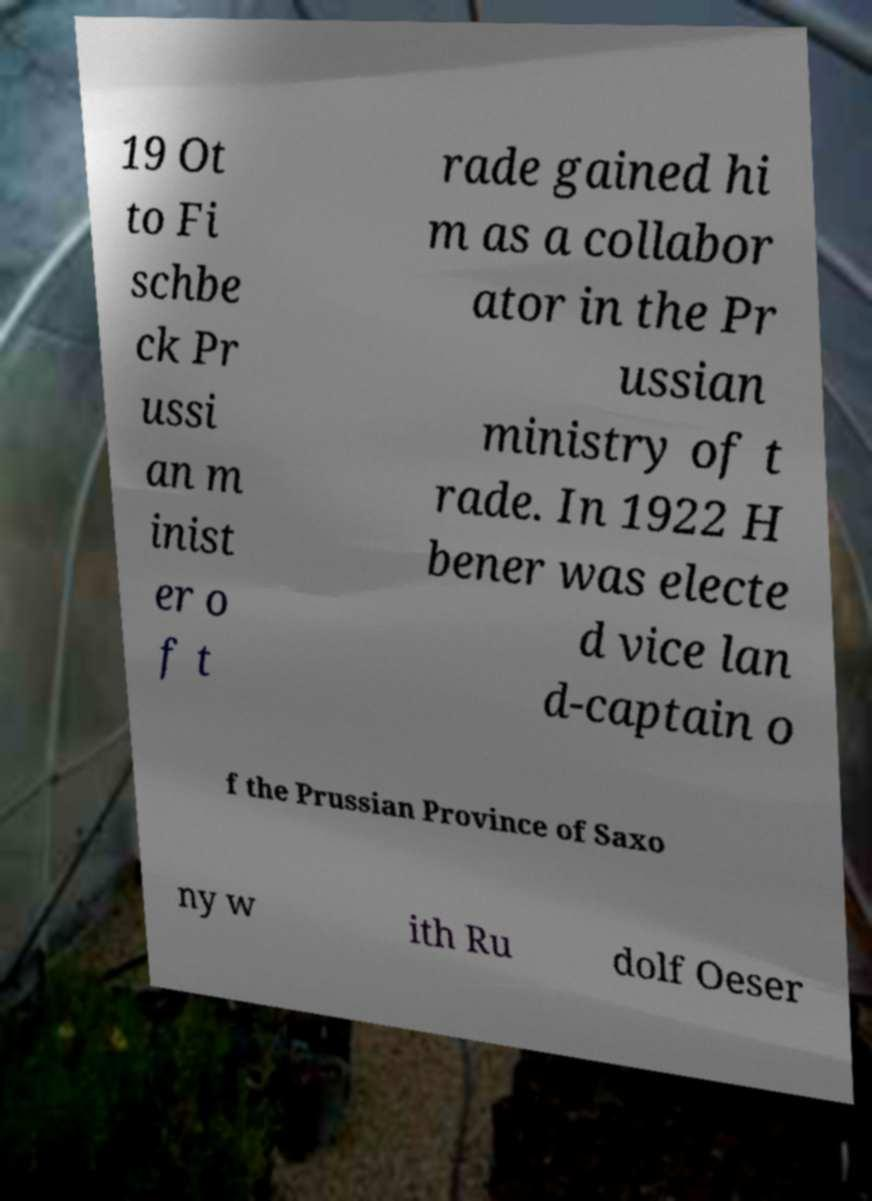Can you accurately transcribe the text from the provided image for me? 19 Ot to Fi schbe ck Pr ussi an m inist er o f t rade gained hi m as a collabor ator in the Pr ussian ministry of t rade. In 1922 H bener was electe d vice lan d-captain o f the Prussian Province of Saxo ny w ith Ru dolf Oeser 